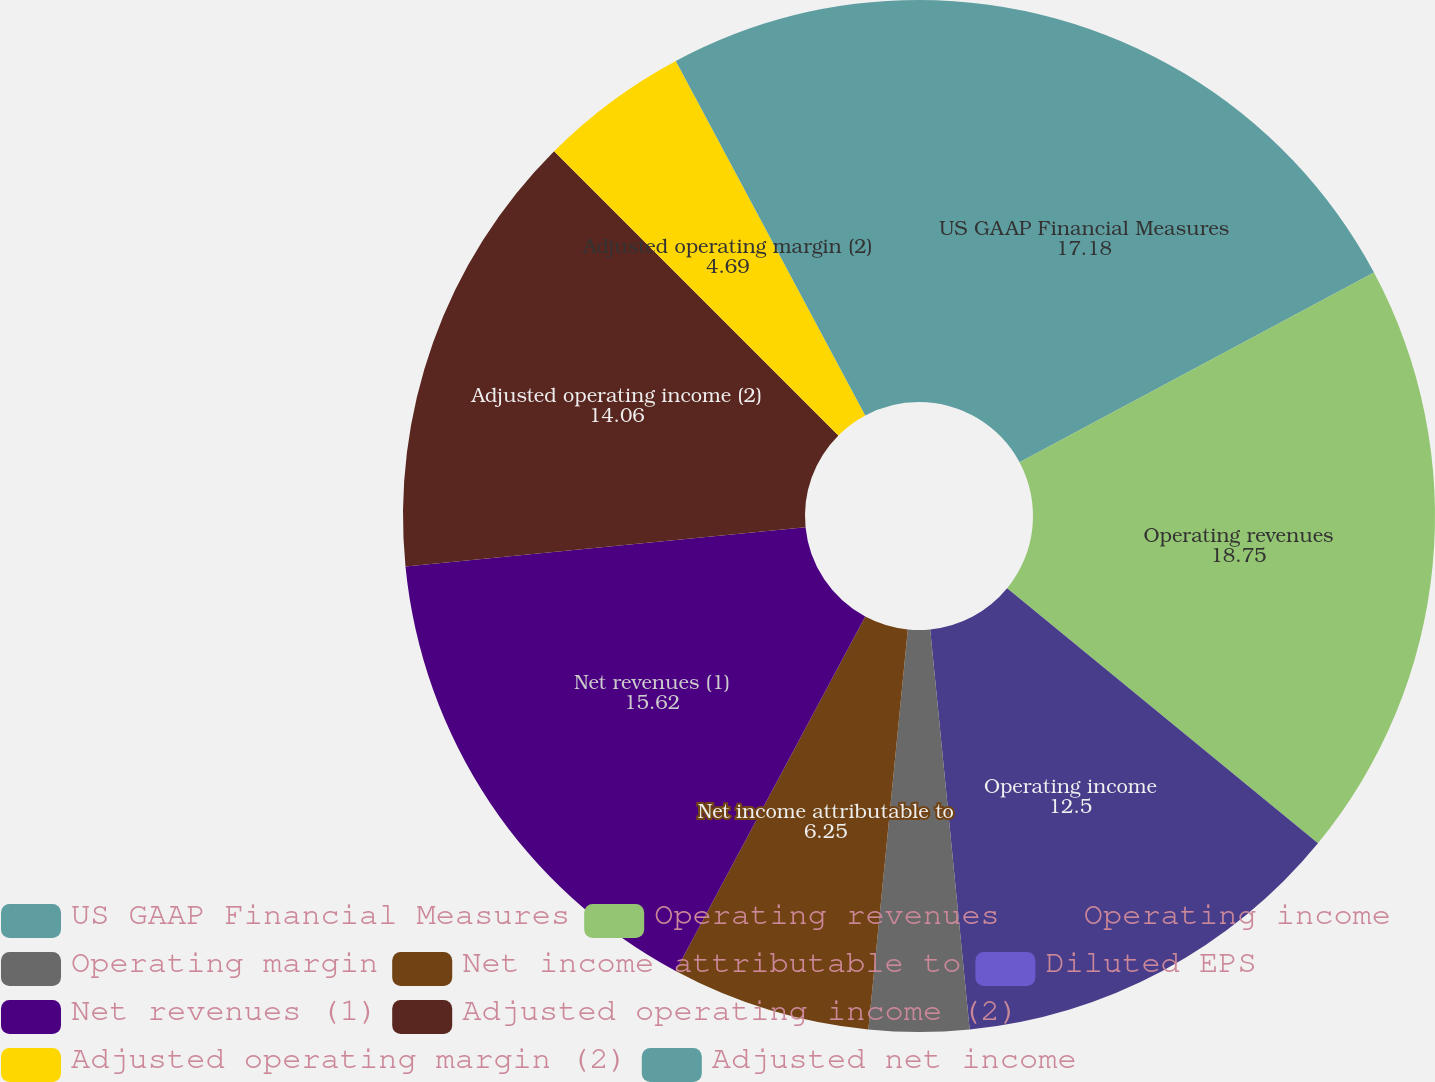<chart> <loc_0><loc_0><loc_500><loc_500><pie_chart><fcel>US GAAP Financial Measures<fcel>Operating revenues<fcel>Operating income<fcel>Operating margin<fcel>Net income attributable to<fcel>Diluted EPS<fcel>Net revenues (1)<fcel>Adjusted operating income (2)<fcel>Adjusted operating margin (2)<fcel>Adjusted net income<nl><fcel>17.18%<fcel>18.75%<fcel>12.5%<fcel>3.13%<fcel>6.25%<fcel>0.0%<fcel>15.62%<fcel>14.06%<fcel>4.69%<fcel>7.81%<nl></chart> 